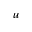<formula> <loc_0><loc_0><loc_500><loc_500>u</formula> 